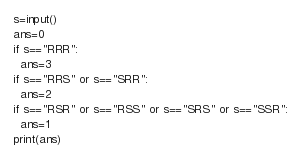<code> <loc_0><loc_0><loc_500><loc_500><_Python_>s=input()
ans=0
if s=="RRR":
  ans=3
if s=="RRS" or s=="SRR":
  ans=2
if s=="RSR" or s=="RSS" or s=="SRS" or s=="SSR":
  ans=1
print(ans)</code> 